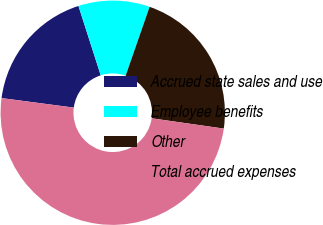Convert chart to OTSL. <chart><loc_0><loc_0><loc_500><loc_500><pie_chart><fcel>Accrued state sales and use<fcel>Employee benefits<fcel>Other<fcel>Total accrued expenses<nl><fcel>17.97%<fcel>10.28%<fcel>21.93%<fcel>49.83%<nl></chart> 